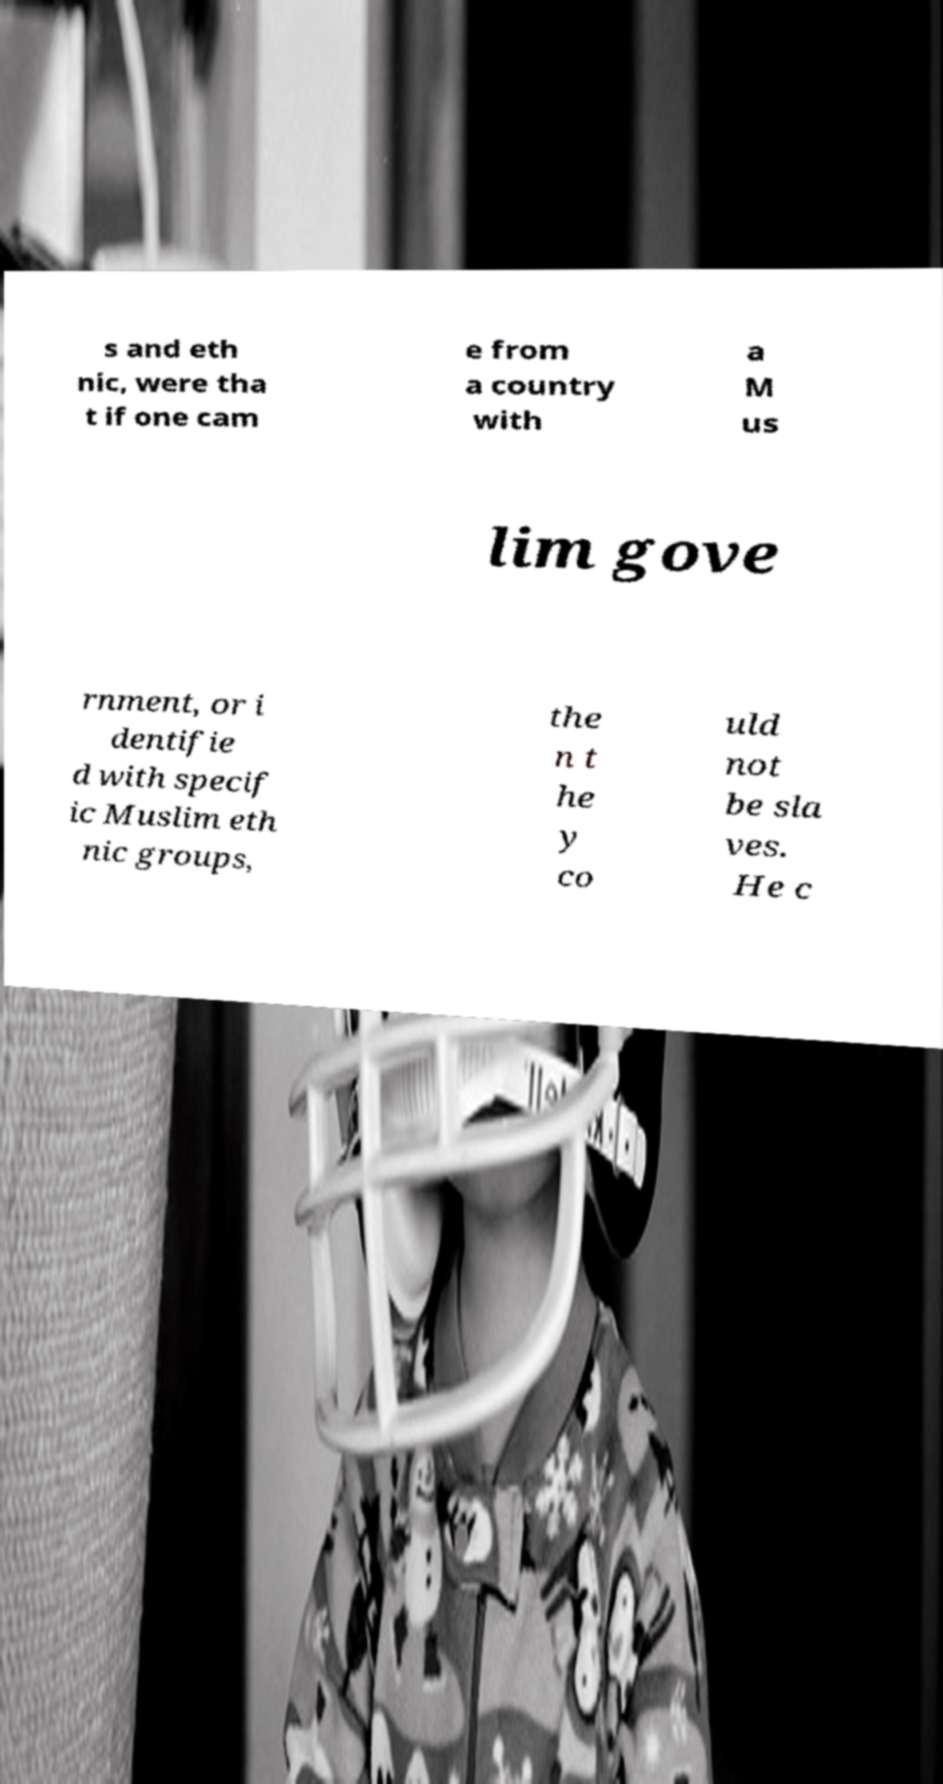Please identify and transcribe the text found in this image. s and eth nic, were tha t if one cam e from a country with a M us lim gove rnment, or i dentifie d with specif ic Muslim eth nic groups, the n t he y co uld not be sla ves. He c 